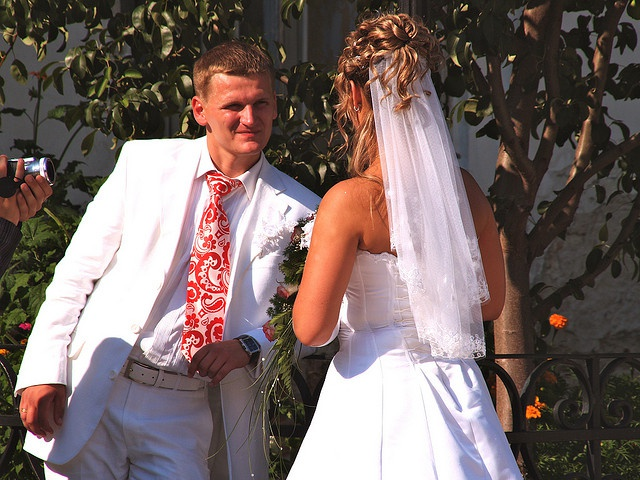Describe the objects in this image and their specific colors. I can see people in black, white, gray, and maroon tones, people in black, lavender, darkgray, and maroon tones, tie in black, red, white, lightpink, and brown tones, and people in black, maroon, and brown tones in this image. 